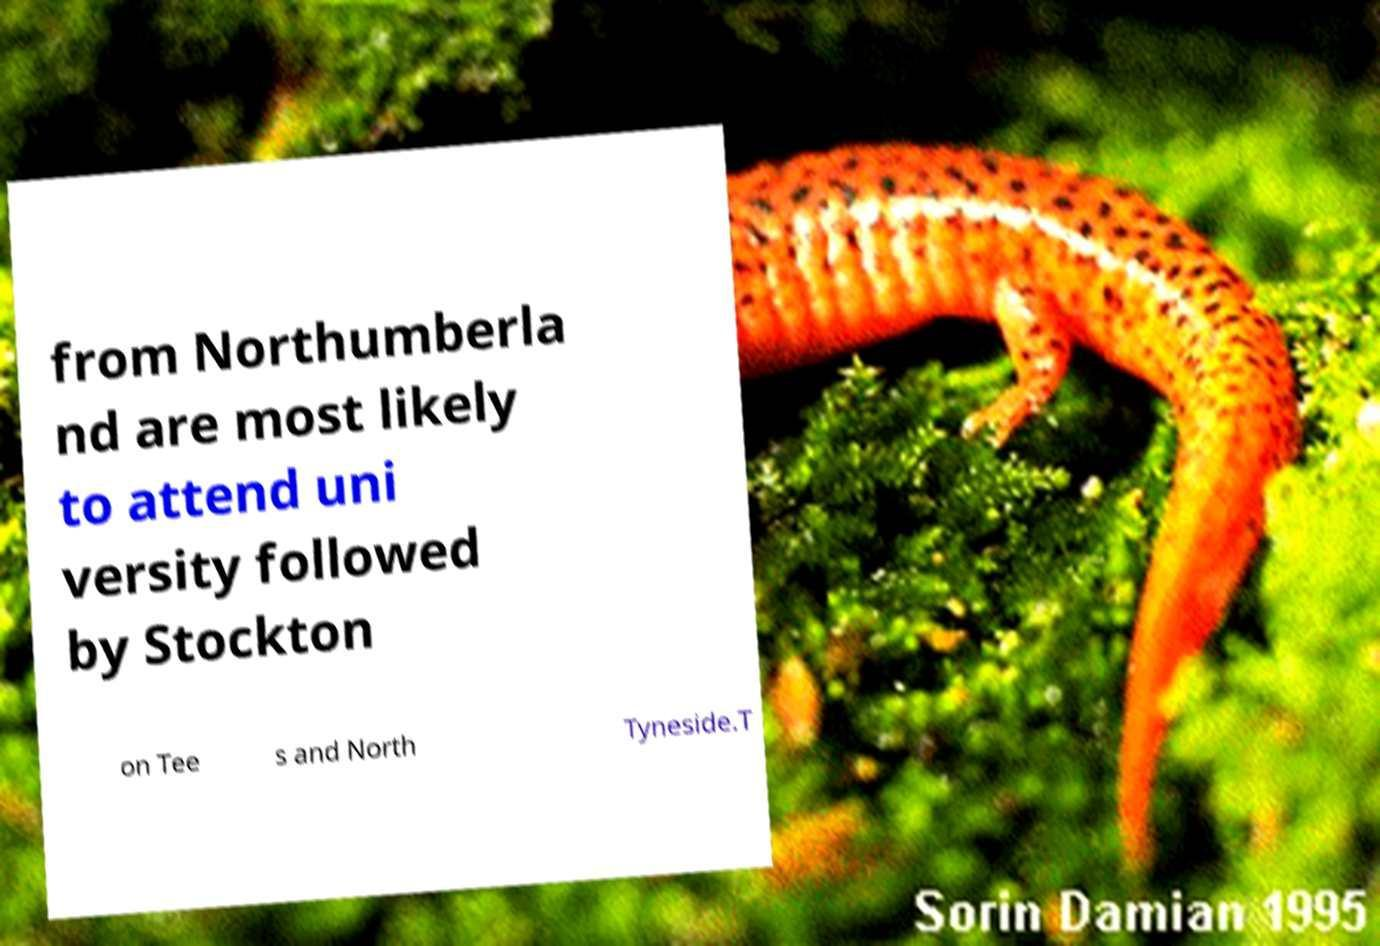There's text embedded in this image that I need extracted. Can you transcribe it verbatim? from Northumberla nd are most likely to attend uni versity followed by Stockton on Tee s and North Tyneside.T 